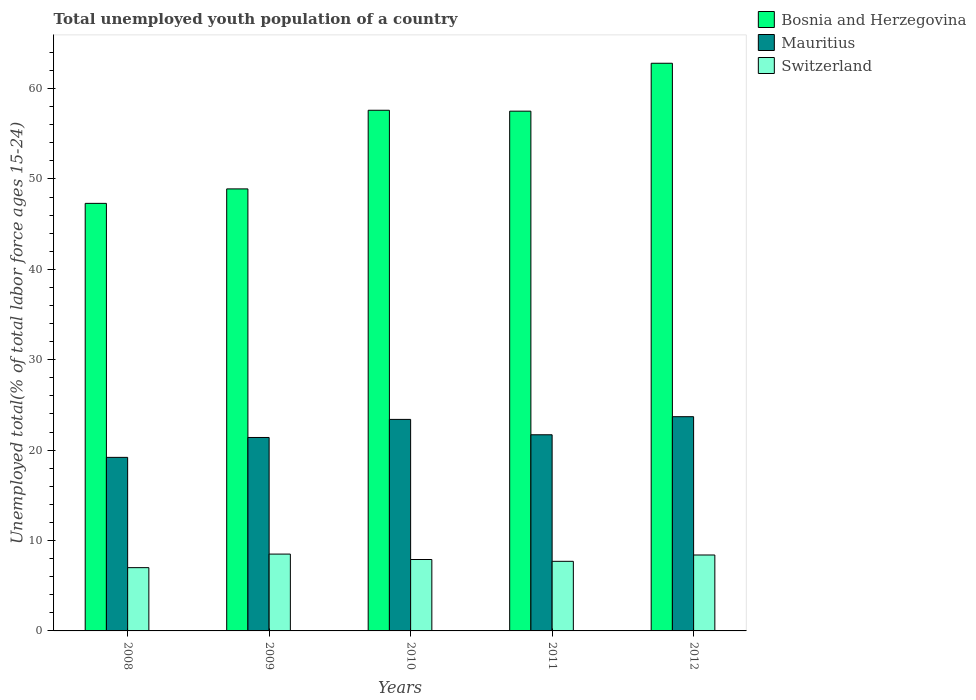How many different coloured bars are there?
Your answer should be compact. 3. How many groups of bars are there?
Make the answer very short. 5. Are the number of bars on each tick of the X-axis equal?
Ensure brevity in your answer.  Yes. In how many cases, is the number of bars for a given year not equal to the number of legend labels?
Keep it short and to the point. 0. What is the percentage of total unemployed youth population of a country in Bosnia and Herzegovina in 2009?
Provide a short and direct response. 48.9. Across all years, what is the maximum percentage of total unemployed youth population of a country in Mauritius?
Offer a very short reply. 23.7. Across all years, what is the minimum percentage of total unemployed youth population of a country in Bosnia and Herzegovina?
Your answer should be compact. 47.3. In which year was the percentage of total unemployed youth population of a country in Bosnia and Herzegovina minimum?
Give a very brief answer. 2008. What is the total percentage of total unemployed youth population of a country in Bosnia and Herzegovina in the graph?
Give a very brief answer. 274.1. What is the difference between the percentage of total unemployed youth population of a country in Switzerland in 2009 and that in 2012?
Provide a succinct answer. 0.1. What is the difference between the percentage of total unemployed youth population of a country in Bosnia and Herzegovina in 2008 and the percentage of total unemployed youth population of a country in Switzerland in 2012?
Your response must be concise. 38.9. What is the average percentage of total unemployed youth population of a country in Bosnia and Herzegovina per year?
Provide a succinct answer. 54.82. In the year 2009, what is the difference between the percentage of total unemployed youth population of a country in Bosnia and Herzegovina and percentage of total unemployed youth population of a country in Mauritius?
Offer a very short reply. 27.5. In how many years, is the percentage of total unemployed youth population of a country in Bosnia and Herzegovina greater than 26 %?
Your answer should be very brief. 5. What is the ratio of the percentage of total unemployed youth population of a country in Mauritius in 2009 to that in 2010?
Provide a short and direct response. 0.91. Is the difference between the percentage of total unemployed youth population of a country in Bosnia and Herzegovina in 2011 and 2012 greater than the difference between the percentage of total unemployed youth population of a country in Mauritius in 2011 and 2012?
Offer a very short reply. No. What is the difference between the highest and the second highest percentage of total unemployed youth population of a country in Bosnia and Herzegovina?
Provide a short and direct response. 5.2. What is the difference between the highest and the lowest percentage of total unemployed youth population of a country in Switzerland?
Offer a very short reply. 1.5. Is the sum of the percentage of total unemployed youth population of a country in Mauritius in 2008 and 2009 greater than the maximum percentage of total unemployed youth population of a country in Bosnia and Herzegovina across all years?
Provide a short and direct response. No. What does the 1st bar from the left in 2010 represents?
Your response must be concise. Bosnia and Herzegovina. What does the 1st bar from the right in 2008 represents?
Your answer should be very brief. Switzerland. Is it the case that in every year, the sum of the percentage of total unemployed youth population of a country in Switzerland and percentage of total unemployed youth population of a country in Bosnia and Herzegovina is greater than the percentage of total unemployed youth population of a country in Mauritius?
Give a very brief answer. Yes. How many bars are there?
Keep it short and to the point. 15. How many years are there in the graph?
Your response must be concise. 5. Are the values on the major ticks of Y-axis written in scientific E-notation?
Ensure brevity in your answer.  No. Where does the legend appear in the graph?
Offer a very short reply. Top right. What is the title of the graph?
Offer a very short reply. Total unemployed youth population of a country. What is the label or title of the Y-axis?
Ensure brevity in your answer.  Unemployed total(% of total labor force ages 15-24). What is the Unemployed total(% of total labor force ages 15-24) in Bosnia and Herzegovina in 2008?
Offer a very short reply. 47.3. What is the Unemployed total(% of total labor force ages 15-24) of Mauritius in 2008?
Your answer should be compact. 19.2. What is the Unemployed total(% of total labor force ages 15-24) of Switzerland in 2008?
Offer a terse response. 7. What is the Unemployed total(% of total labor force ages 15-24) in Bosnia and Herzegovina in 2009?
Keep it short and to the point. 48.9. What is the Unemployed total(% of total labor force ages 15-24) in Mauritius in 2009?
Ensure brevity in your answer.  21.4. What is the Unemployed total(% of total labor force ages 15-24) of Bosnia and Herzegovina in 2010?
Ensure brevity in your answer.  57.6. What is the Unemployed total(% of total labor force ages 15-24) of Mauritius in 2010?
Your answer should be compact. 23.4. What is the Unemployed total(% of total labor force ages 15-24) of Switzerland in 2010?
Give a very brief answer. 7.9. What is the Unemployed total(% of total labor force ages 15-24) of Bosnia and Herzegovina in 2011?
Keep it short and to the point. 57.5. What is the Unemployed total(% of total labor force ages 15-24) in Mauritius in 2011?
Offer a terse response. 21.7. What is the Unemployed total(% of total labor force ages 15-24) in Switzerland in 2011?
Provide a succinct answer. 7.7. What is the Unemployed total(% of total labor force ages 15-24) of Bosnia and Herzegovina in 2012?
Your answer should be compact. 62.8. What is the Unemployed total(% of total labor force ages 15-24) in Mauritius in 2012?
Make the answer very short. 23.7. What is the Unemployed total(% of total labor force ages 15-24) of Switzerland in 2012?
Offer a terse response. 8.4. Across all years, what is the maximum Unemployed total(% of total labor force ages 15-24) in Bosnia and Herzegovina?
Your response must be concise. 62.8. Across all years, what is the maximum Unemployed total(% of total labor force ages 15-24) of Mauritius?
Keep it short and to the point. 23.7. Across all years, what is the minimum Unemployed total(% of total labor force ages 15-24) in Bosnia and Herzegovina?
Ensure brevity in your answer.  47.3. Across all years, what is the minimum Unemployed total(% of total labor force ages 15-24) in Mauritius?
Your answer should be very brief. 19.2. Across all years, what is the minimum Unemployed total(% of total labor force ages 15-24) in Switzerland?
Your answer should be compact. 7. What is the total Unemployed total(% of total labor force ages 15-24) in Bosnia and Herzegovina in the graph?
Your answer should be compact. 274.1. What is the total Unemployed total(% of total labor force ages 15-24) of Mauritius in the graph?
Make the answer very short. 109.4. What is the total Unemployed total(% of total labor force ages 15-24) of Switzerland in the graph?
Provide a short and direct response. 39.5. What is the difference between the Unemployed total(% of total labor force ages 15-24) in Mauritius in 2008 and that in 2009?
Offer a very short reply. -2.2. What is the difference between the Unemployed total(% of total labor force ages 15-24) in Switzerland in 2008 and that in 2009?
Your response must be concise. -1.5. What is the difference between the Unemployed total(% of total labor force ages 15-24) in Switzerland in 2008 and that in 2011?
Ensure brevity in your answer.  -0.7. What is the difference between the Unemployed total(% of total labor force ages 15-24) of Bosnia and Herzegovina in 2008 and that in 2012?
Your answer should be very brief. -15.5. What is the difference between the Unemployed total(% of total labor force ages 15-24) of Mauritius in 2008 and that in 2012?
Make the answer very short. -4.5. What is the difference between the Unemployed total(% of total labor force ages 15-24) in Switzerland in 2008 and that in 2012?
Provide a short and direct response. -1.4. What is the difference between the Unemployed total(% of total labor force ages 15-24) in Mauritius in 2009 and that in 2010?
Provide a short and direct response. -2. What is the difference between the Unemployed total(% of total labor force ages 15-24) of Switzerland in 2009 and that in 2010?
Your response must be concise. 0.6. What is the difference between the Unemployed total(% of total labor force ages 15-24) in Bosnia and Herzegovina in 2009 and that in 2011?
Your answer should be compact. -8.6. What is the difference between the Unemployed total(% of total labor force ages 15-24) in Mauritius in 2009 and that in 2011?
Offer a very short reply. -0.3. What is the difference between the Unemployed total(% of total labor force ages 15-24) in Bosnia and Herzegovina in 2009 and that in 2012?
Offer a very short reply. -13.9. What is the difference between the Unemployed total(% of total labor force ages 15-24) of Switzerland in 2009 and that in 2012?
Provide a succinct answer. 0.1. What is the difference between the Unemployed total(% of total labor force ages 15-24) in Bosnia and Herzegovina in 2010 and that in 2012?
Provide a short and direct response. -5.2. What is the difference between the Unemployed total(% of total labor force ages 15-24) of Mauritius in 2010 and that in 2012?
Give a very brief answer. -0.3. What is the difference between the Unemployed total(% of total labor force ages 15-24) of Switzerland in 2010 and that in 2012?
Your answer should be compact. -0.5. What is the difference between the Unemployed total(% of total labor force ages 15-24) in Switzerland in 2011 and that in 2012?
Give a very brief answer. -0.7. What is the difference between the Unemployed total(% of total labor force ages 15-24) of Bosnia and Herzegovina in 2008 and the Unemployed total(% of total labor force ages 15-24) of Mauritius in 2009?
Offer a terse response. 25.9. What is the difference between the Unemployed total(% of total labor force ages 15-24) of Bosnia and Herzegovina in 2008 and the Unemployed total(% of total labor force ages 15-24) of Switzerland in 2009?
Your answer should be compact. 38.8. What is the difference between the Unemployed total(% of total labor force ages 15-24) of Bosnia and Herzegovina in 2008 and the Unemployed total(% of total labor force ages 15-24) of Mauritius in 2010?
Keep it short and to the point. 23.9. What is the difference between the Unemployed total(% of total labor force ages 15-24) in Bosnia and Herzegovina in 2008 and the Unemployed total(% of total labor force ages 15-24) in Switzerland in 2010?
Offer a very short reply. 39.4. What is the difference between the Unemployed total(% of total labor force ages 15-24) of Mauritius in 2008 and the Unemployed total(% of total labor force ages 15-24) of Switzerland in 2010?
Make the answer very short. 11.3. What is the difference between the Unemployed total(% of total labor force ages 15-24) in Bosnia and Herzegovina in 2008 and the Unemployed total(% of total labor force ages 15-24) in Mauritius in 2011?
Offer a terse response. 25.6. What is the difference between the Unemployed total(% of total labor force ages 15-24) of Bosnia and Herzegovina in 2008 and the Unemployed total(% of total labor force ages 15-24) of Switzerland in 2011?
Make the answer very short. 39.6. What is the difference between the Unemployed total(% of total labor force ages 15-24) in Mauritius in 2008 and the Unemployed total(% of total labor force ages 15-24) in Switzerland in 2011?
Offer a very short reply. 11.5. What is the difference between the Unemployed total(% of total labor force ages 15-24) in Bosnia and Herzegovina in 2008 and the Unemployed total(% of total labor force ages 15-24) in Mauritius in 2012?
Provide a short and direct response. 23.6. What is the difference between the Unemployed total(% of total labor force ages 15-24) of Bosnia and Herzegovina in 2008 and the Unemployed total(% of total labor force ages 15-24) of Switzerland in 2012?
Make the answer very short. 38.9. What is the difference between the Unemployed total(% of total labor force ages 15-24) in Mauritius in 2009 and the Unemployed total(% of total labor force ages 15-24) in Switzerland in 2010?
Your answer should be very brief. 13.5. What is the difference between the Unemployed total(% of total labor force ages 15-24) of Bosnia and Herzegovina in 2009 and the Unemployed total(% of total labor force ages 15-24) of Mauritius in 2011?
Ensure brevity in your answer.  27.2. What is the difference between the Unemployed total(% of total labor force ages 15-24) in Bosnia and Herzegovina in 2009 and the Unemployed total(% of total labor force ages 15-24) in Switzerland in 2011?
Your answer should be compact. 41.2. What is the difference between the Unemployed total(% of total labor force ages 15-24) of Bosnia and Herzegovina in 2009 and the Unemployed total(% of total labor force ages 15-24) of Mauritius in 2012?
Give a very brief answer. 25.2. What is the difference between the Unemployed total(% of total labor force ages 15-24) in Bosnia and Herzegovina in 2009 and the Unemployed total(% of total labor force ages 15-24) in Switzerland in 2012?
Ensure brevity in your answer.  40.5. What is the difference between the Unemployed total(% of total labor force ages 15-24) in Bosnia and Herzegovina in 2010 and the Unemployed total(% of total labor force ages 15-24) in Mauritius in 2011?
Ensure brevity in your answer.  35.9. What is the difference between the Unemployed total(% of total labor force ages 15-24) of Bosnia and Herzegovina in 2010 and the Unemployed total(% of total labor force ages 15-24) of Switzerland in 2011?
Keep it short and to the point. 49.9. What is the difference between the Unemployed total(% of total labor force ages 15-24) of Mauritius in 2010 and the Unemployed total(% of total labor force ages 15-24) of Switzerland in 2011?
Keep it short and to the point. 15.7. What is the difference between the Unemployed total(% of total labor force ages 15-24) in Bosnia and Herzegovina in 2010 and the Unemployed total(% of total labor force ages 15-24) in Mauritius in 2012?
Provide a short and direct response. 33.9. What is the difference between the Unemployed total(% of total labor force ages 15-24) of Bosnia and Herzegovina in 2010 and the Unemployed total(% of total labor force ages 15-24) of Switzerland in 2012?
Ensure brevity in your answer.  49.2. What is the difference between the Unemployed total(% of total labor force ages 15-24) of Bosnia and Herzegovina in 2011 and the Unemployed total(% of total labor force ages 15-24) of Mauritius in 2012?
Offer a terse response. 33.8. What is the difference between the Unemployed total(% of total labor force ages 15-24) of Bosnia and Herzegovina in 2011 and the Unemployed total(% of total labor force ages 15-24) of Switzerland in 2012?
Make the answer very short. 49.1. What is the average Unemployed total(% of total labor force ages 15-24) of Bosnia and Herzegovina per year?
Your answer should be very brief. 54.82. What is the average Unemployed total(% of total labor force ages 15-24) of Mauritius per year?
Your answer should be compact. 21.88. In the year 2008, what is the difference between the Unemployed total(% of total labor force ages 15-24) of Bosnia and Herzegovina and Unemployed total(% of total labor force ages 15-24) of Mauritius?
Offer a very short reply. 28.1. In the year 2008, what is the difference between the Unemployed total(% of total labor force ages 15-24) in Bosnia and Herzegovina and Unemployed total(% of total labor force ages 15-24) in Switzerland?
Offer a terse response. 40.3. In the year 2009, what is the difference between the Unemployed total(% of total labor force ages 15-24) of Bosnia and Herzegovina and Unemployed total(% of total labor force ages 15-24) of Switzerland?
Give a very brief answer. 40.4. In the year 2009, what is the difference between the Unemployed total(% of total labor force ages 15-24) of Mauritius and Unemployed total(% of total labor force ages 15-24) of Switzerland?
Give a very brief answer. 12.9. In the year 2010, what is the difference between the Unemployed total(% of total labor force ages 15-24) in Bosnia and Herzegovina and Unemployed total(% of total labor force ages 15-24) in Mauritius?
Give a very brief answer. 34.2. In the year 2010, what is the difference between the Unemployed total(% of total labor force ages 15-24) of Bosnia and Herzegovina and Unemployed total(% of total labor force ages 15-24) of Switzerland?
Your answer should be very brief. 49.7. In the year 2010, what is the difference between the Unemployed total(% of total labor force ages 15-24) in Mauritius and Unemployed total(% of total labor force ages 15-24) in Switzerland?
Provide a short and direct response. 15.5. In the year 2011, what is the difference between the Unemployed total(% of total labor force ages 15-24) in Bosnia and Herzegovina and Unemployed total(% of total labor force ages 15-24) in Mauritius?
Your answer should be compact. 35.8. In the year 2011, what is the difference between the Unemployed total(% of total labor force ages 15-24) in Bosnia and Herzegovina and Unemployed total(% of total labor force ages 15-24) in Switzerland?
Make the answer very short. 49.8. In the year 2012, what is the difference between the Unemployed total(% of total labor force ages 15-24) of Bosnia and Herzegovina and Unemployed total(% of total labor force ages 15-24) of Mauritius?
Keep it short and to the point. 39.1. In the year 2012, what is the difference between the Unemployed total(% of total labor force ages 15-24) of Bosnia and Herzegovina and Unemployed total(% of total labor force ages 15-24) of Switzerland?
Your answer should be compact. 54.4. In the year 2012, what is the difference between the Unemployed total(% of total labor force ages 15-24) in Mauritius and Unemployed total(% of total labor force ages 15-24) in Switzerland?
Your answer should be very brief. 15.3. What is the ratio of the Unemployed total(% of total labor force ages 15-24) of Bosnia and Herzegovina in 2008 to that in 2009?
Provide a short and direct response. 0.97. What is the ratio of the Unemployed total(% of total labor force ages 15-24) of Mauritius in 2008 to that in 2009?
Provide a succinct answer. 0.9. What is the ratio of the Unemployed total(% of total labor force ages 15-24) of Switzerland in 2008 to that in 2009?
Your answer should be very brief. 0.82. What is the ratio of the Unemployed total(% of total labor force ages 15-24) in Bosnia and Herzegovina in 2008 to that in 2010?
Offer a very short reply. 0.82. What is the ratio of the Unemployed total(% of total labor force ages 15-24) of Mauritius in 2008 to that in 2010?
Your response must be concise. 0.82. What is the ratio of the Unemployed total(% of total labor force ages 15-24) of Switzerland in 2008 to that in 2010?
Make the answer very short. 0.89. What is the ratio of the Unemployed total(% of total labor force ages 15-24) of Bosnia and Herzegovina in 2008 to that in 2011?
Offer a terse response. 0.82. What is the ratio of the Unemployed total(% of total labor force ages 15-24) in Mauritius in 2008 to that in 2011?
Offer a terse response. 0.88. What is the ratio of the Unemployed total(% of total labor force ages 15-24) of Switzerland in 2008 to that in 2011?
Give a very brief answer. 0.91. What is the ratio of the Unemployed total(% of total labor force ages 15-24) of Bosnia and Herzegovina in 2008 to that in 2012?
Offer a terse response. 0.75. What is the ratio of the Unemployed total(% of total labor force ages 15-24) of Mauritius in 2008 to that in 2012?
Ensure brevity in your answer.  0.81. What is the ratio of the Unemployed total(% of total labor force ages 15-24) in Switzerland in 2008 to that in 2012?
Your answer should be compact. 0.83. What is the ratio of the Unemployed total(% of total labor force ages 15-24) of Bosnia and Herzegovina in 2009 to that in 2010?
Make the answer very short. 0.85. What is the ratio of the Unemployed total(% of total labor force ages 15-24) in Mauritius in 2009 to that in 2010?
Make the answer very short. 0.91. What is the ratio of the Unemployed total(% of total labor force ages 15-24) in Switzerland in 2009 to that in 2010?
Provide a short and direct response. 1.08. What is the ratio of the Unemployed total(% of total labor force ages 15-24) in Bosnia and Herzegovina in 2009 to that in 2011?
Give a very brief answer. 0.85. What is the ratio of the Unemployed total(% of total labor force ages 15-24) of Mauritius in 2009 to that in 2011?
Give a very brief answer. 0.99. What is the ratio of the Unemployed total(% of total labor force ages 15-24) of Switzerland in 2009 to that in 2011?
Your response must be concise. 1.1. What is the ratio of the Unemployed total(% of total labor force ages 15-24) of Bosnia and Herzegovina in 2009 to that in 2012?
Provide a short and direct response. 0.78. What is the ratio of the Unemployed total(% of total labor force ages 15-24) of Mauritius in 2009 to that in 2012?
Provide a succinct answer. 0.9. What is the ratio of the Unemployed total(% of total labor force ages 15-24) in Switzerland in 2009 to that in 2012?
Your answer should be compact. 1.01. What is the ratio of the Unemployed total(% of total labor force ages 15-24) in Bosnia and Herzegovina in 2010 to that in 2011?
Your answer should be very brief. 1. What is the ratio of the Unemployed total(% of total labor force ages 15-24) in Mauritius in 2010 to that in 2011?
Your answer should be compact. 1.08. What is the ratio of the Unemployed total(% of total labor force ages 15-24) of Switzerland in 2010 to that in 2011?
Offer a terse response. 1.03. What is the ratio of the Unemployed total(% of total labor force ages 15-24) in Bosnia and Herzegovina in 2010 to that in 2012?
Provide a short and direct response. 0.92. What is the ratio of the Unemployed total(% of total labor force ages 15-24) of Mauritius in 2010 to that in 2012?
Offer a very short reply. 0.99. What is the ratio of the Unemployed total(% of total labor force ages 15-24) in Switzerland in 2010 to that in 2012?
Offer a very short reply. 0.94. What is the ratio of the Unemployed total(% of total labor force ages 15-24) in Bosnia and Herzegovina in 2011 to that in 2012?
Your answer should be very brief. 0.92. What is the ratio of the Unemployed total(% of total labor force ages 15-24) in Mauritius in 2011 to that in 2012?
Your response must be concise. 0.92. What is the difference between the highest and the lowest Unemployed total(% of total labor force ages 15-24) in Mauritius?
Offer a terse response. 4.5. 